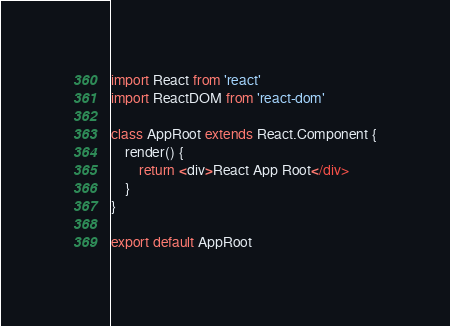<code> <loc_0><loc_0><loc_500><loc_500><_JavaScript_>import React from 'react'
import ReactDOM from 'react-dom'

class AppRoot extends React.Component {
	render() {
		return <div>React App Root</div>
	}
}

export default AppRoot</code> 